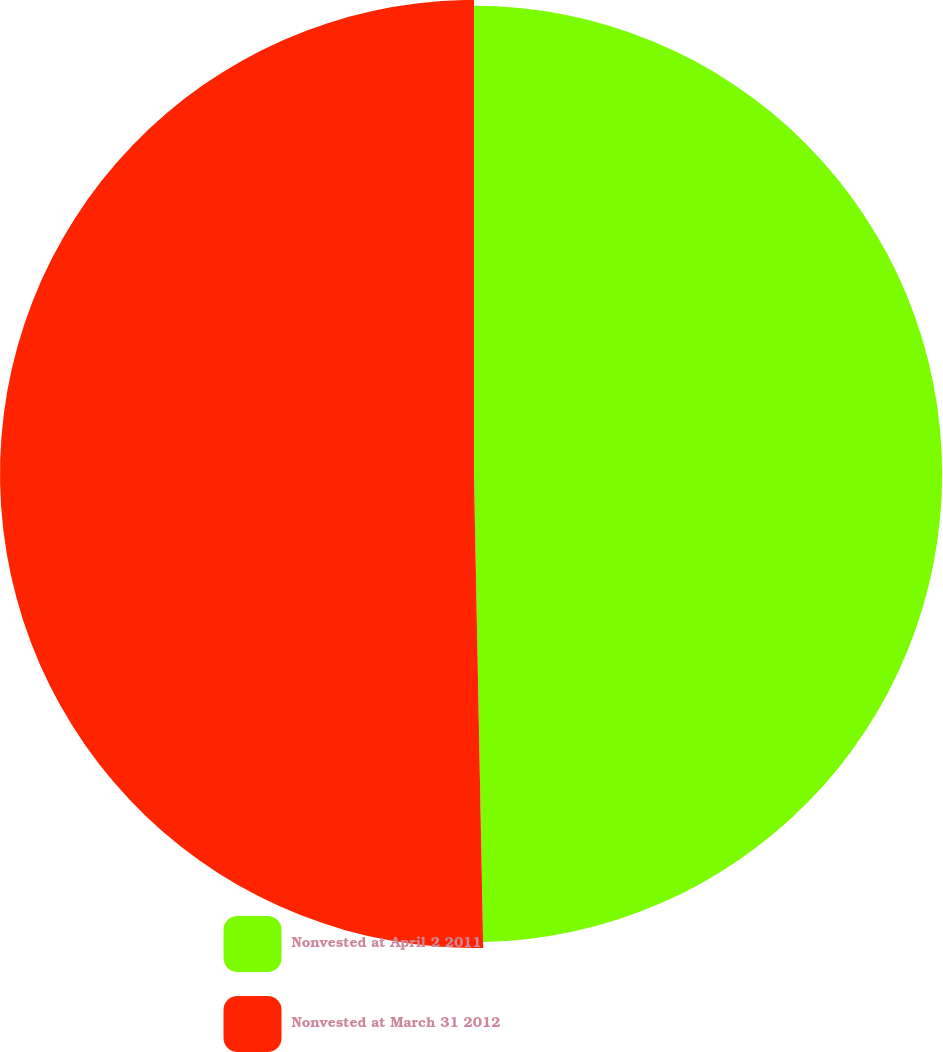<chart> <loc_0><loc_0><loc_500><loc_500><pie_chart><fcel>Nonvested at April 2 2011<fcel>Nonvested at March 31 2012<nl><fcel>49.69%<fcel>50.31%<nl></chart> 